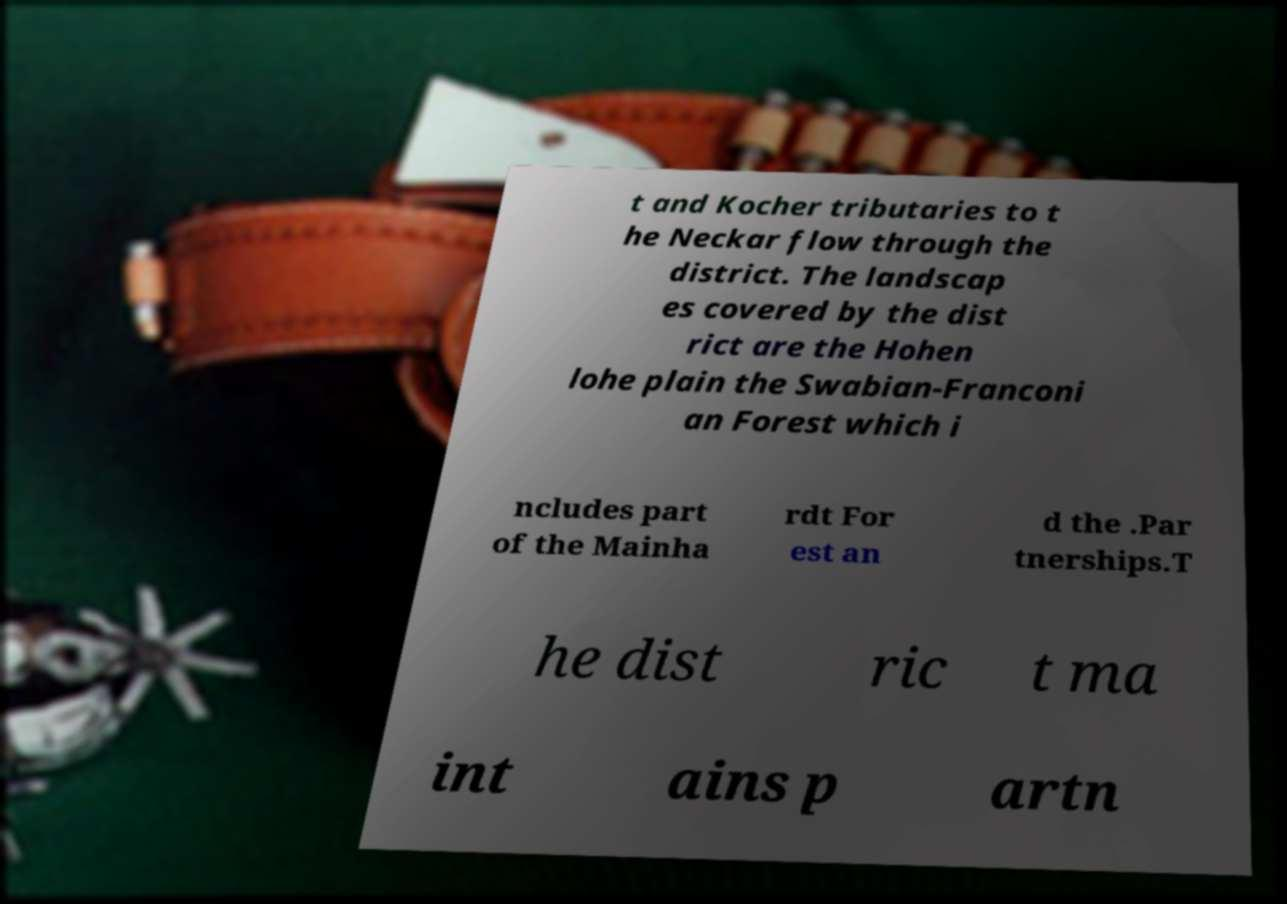For documentation purposes, I need the text within this image transcribed. Could you provide that? t and Kocher tributaries to t he Neckar flow through the district. The landscap es covered by the dist rict are the Hohen lohe plain the Swabian-Franconi an Forest which i ncludes part of the Mainha rdt For est an d the .Par tnerships.T he dist ric t ma int ains p artn 